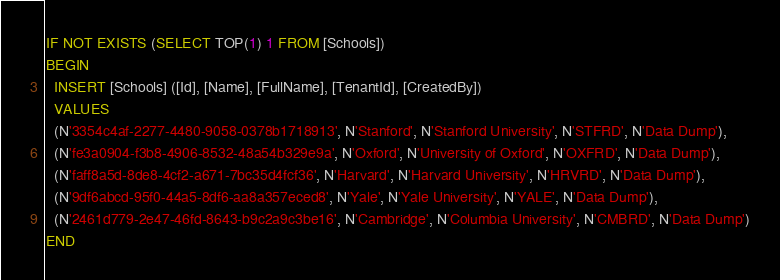<code> <loc_0><loc_0><loc_500><loc_500><_SQL_>IF NOT EXISTS (SELECT TOP(1) 1 FROM [Schools])
BEGIN
  INSERT [Schools] ([Id], [Name], [FullName], [TenantId], [CreatedBy])
  VALUES
  (N'3354c4af-2277-4480-9058-0378b1718913', N'Stanford', N'Stanford University', N'STFRD', N'Data Dump'),
  (N'fe3a0904-f3b8-4906-8532-48a54b329e9a', N'Oxford', N'University of Oxford', N'OXFRD', N'Data Dump'),
  (N'faff8a5d-8de8-4cf2-a671-7bc35d4fcf36', N'Harvard', N'Harvard University', N'HRVRD', N'Data Dump'),
  (N'9df6abcd-95f0-44a5-8df6-aa8a357eced8', N'Yale', N'Yale University', N'YALE', N'Data Dump'),
  (N'2461d779-2e47-46fd-8643-b9c2a9c3be16', N'Cambridge', N'Columbia University', N'CMBRD', N'Data Dump')
END
</code> 